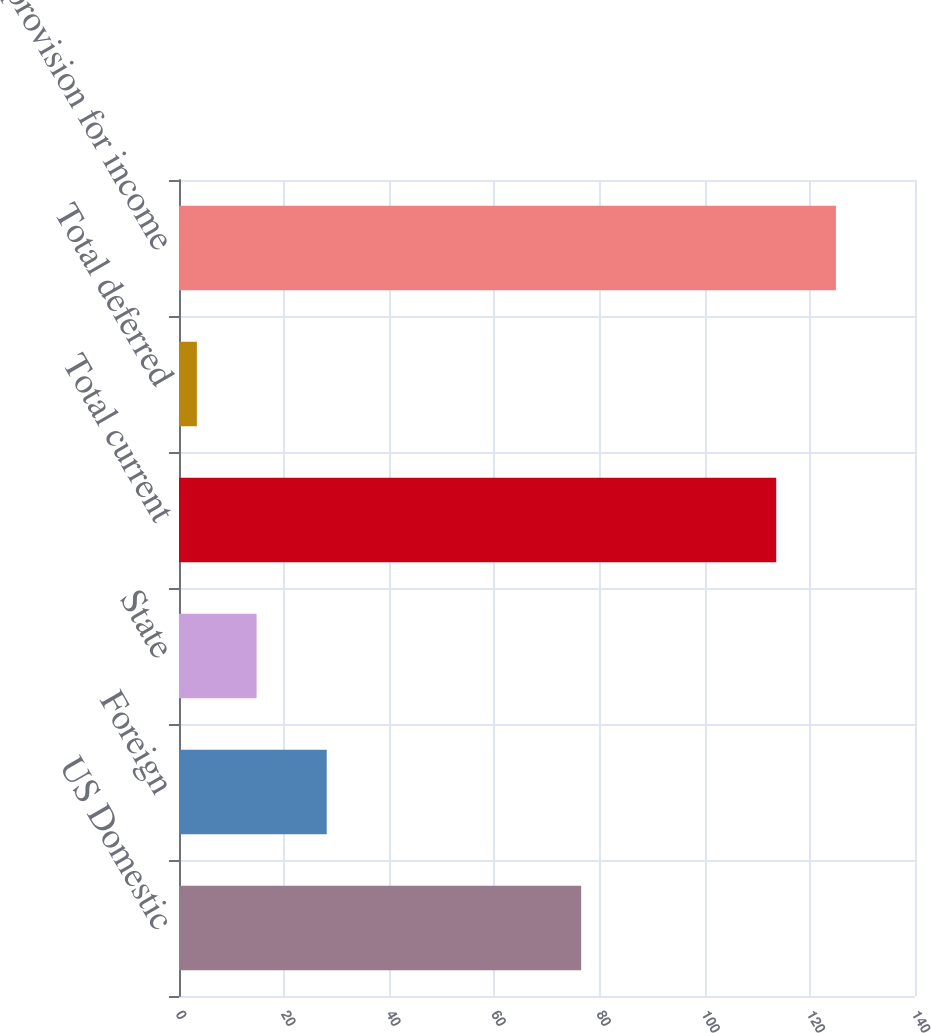Convert chart. <chart><loc_0><loc_0><loc_500><loc_500><bar_chart><fcel>US Domestic<fcel>Foreign<fcel>State<fcel>Total current<fcel>Total deferred<fcel>Total provision for income<nl><fcel>76.5<fcel>28.1<fcel>14.76<fcel>113.6<fcel>3.4<fcel>124.96<nl></chart> 